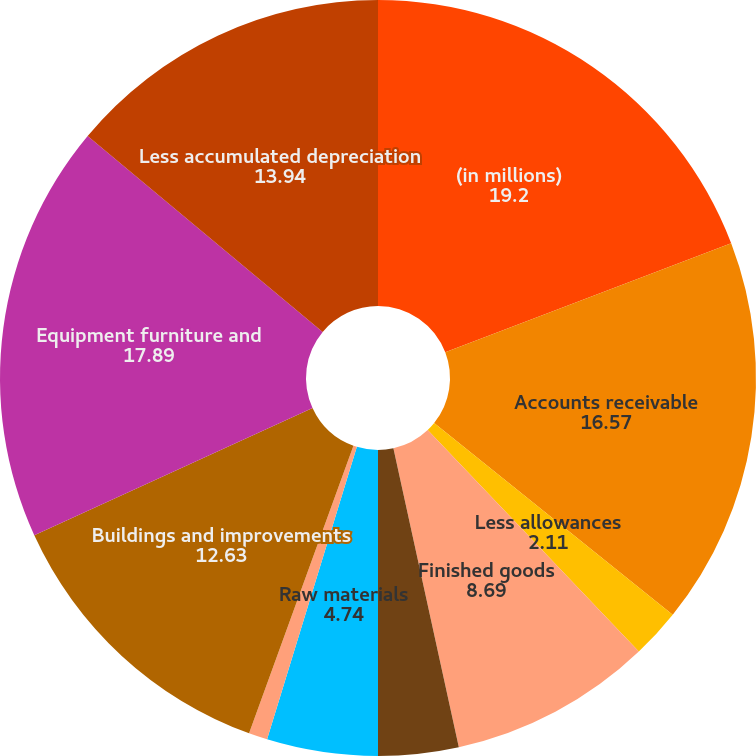Convert chart to OTSL. <chart><loc_0><loc_0><loc_500><loc_500><pie_chart><fcel>(in millions)<fcel>Accounts receivable<fcel>Less allowances<fcel>Finished goods<fcel>Work-in-process<fcel>Raw materials<fcel>Land<fcel>Buildings and improvements<fcel>Equipment furniture and<fcel>Less accumulated depreciation<nl><fcel>19.2%<fcel>16.57%<fcel>2.11%<fcel>8.69%<fcel>3.43%<fcel>4.74%<fcel>0.8%<fcel>12.63%<fcel>17.89%<fcel>13.94%<nl></chart> 